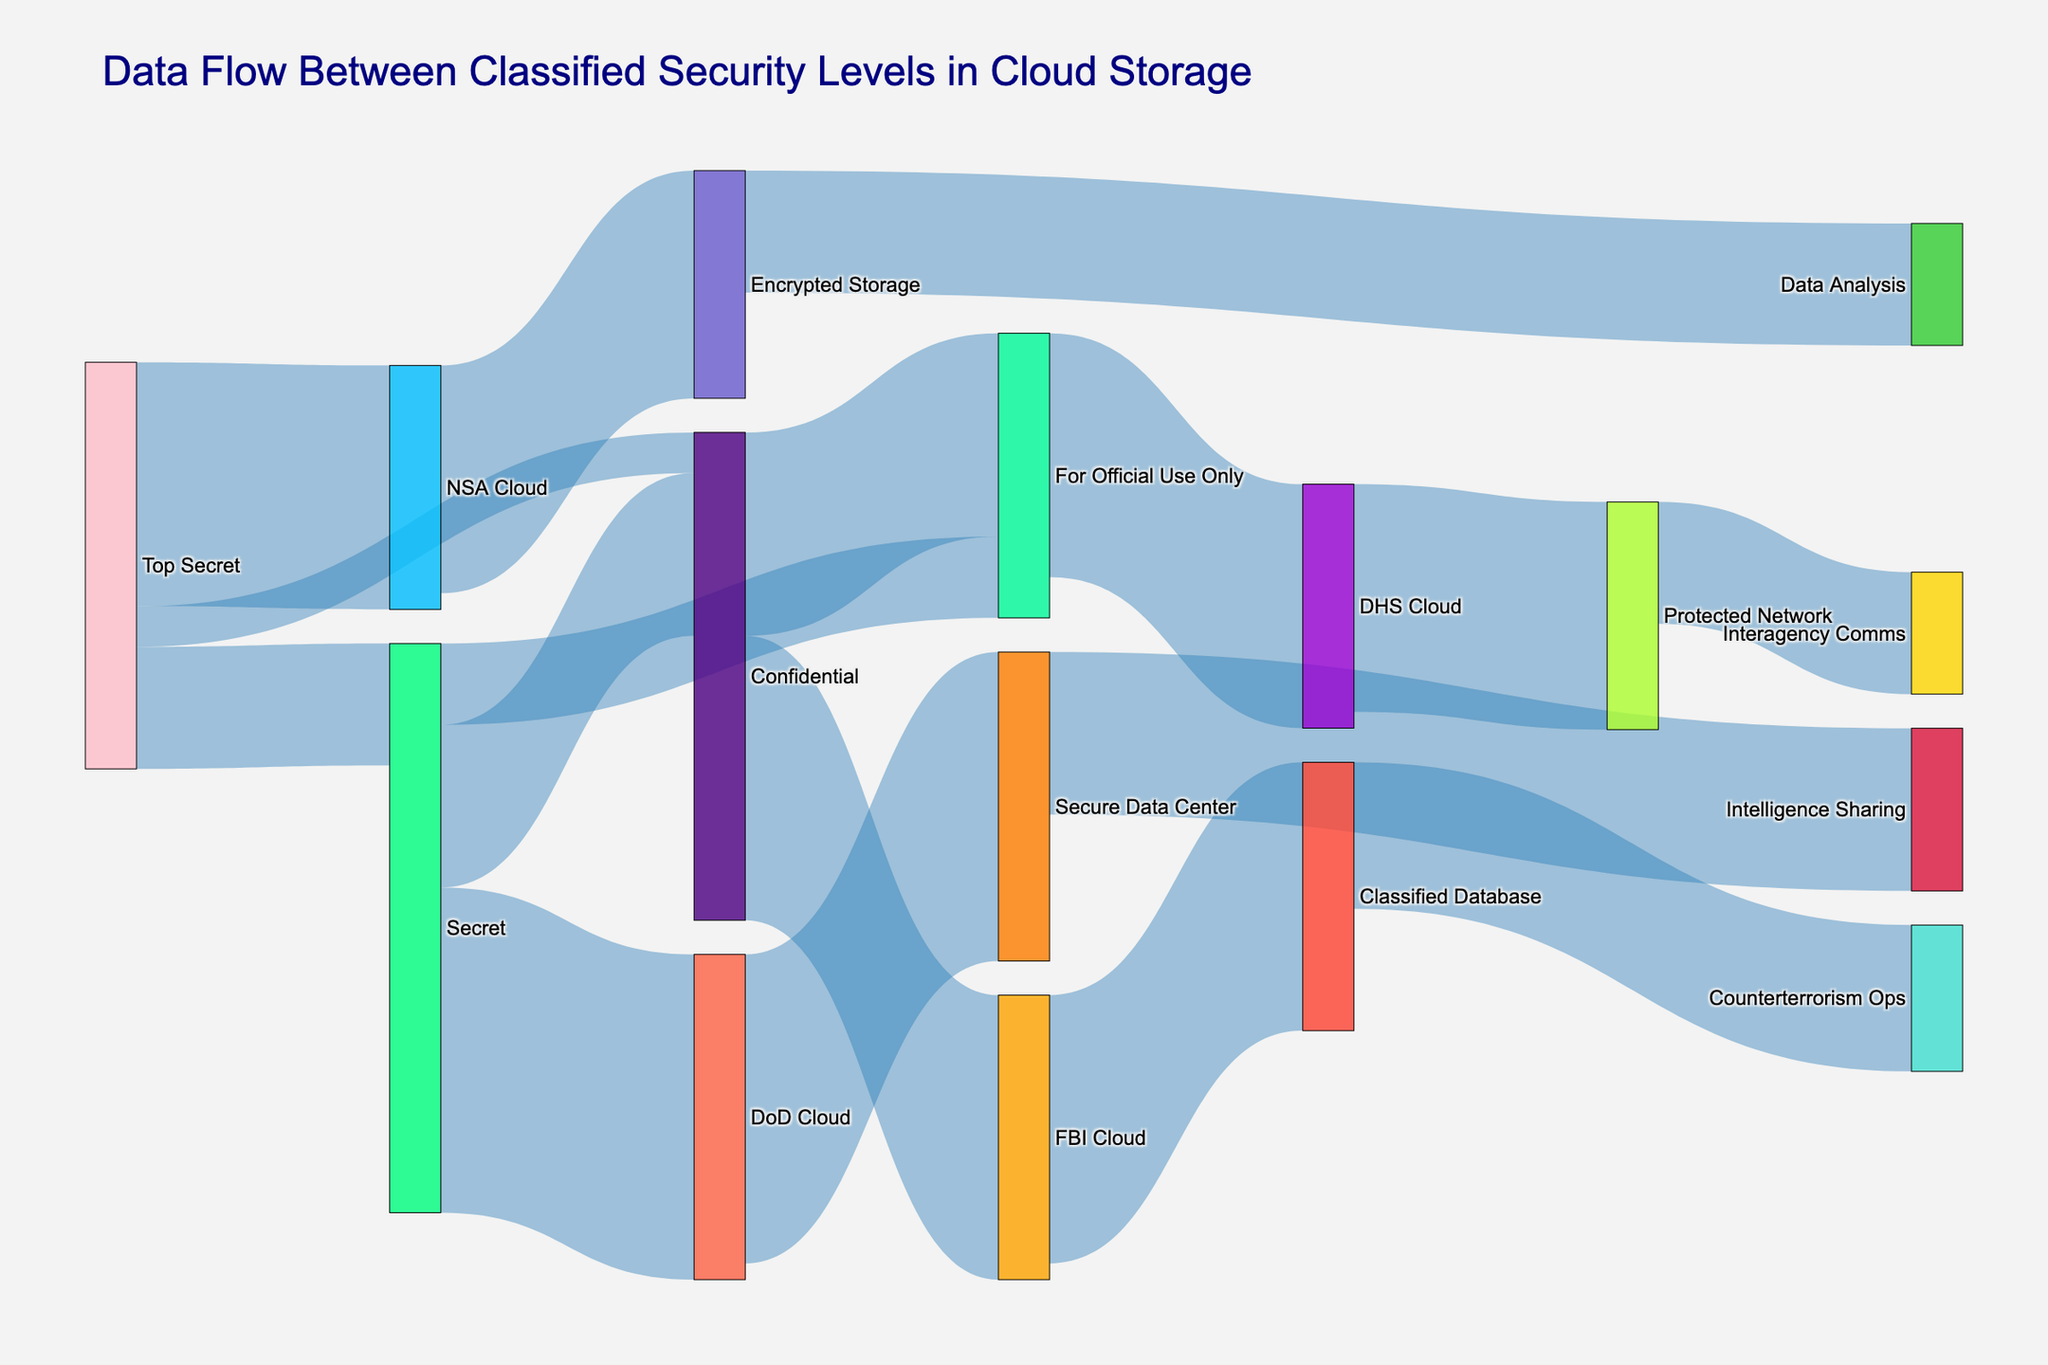What's the total data flow from "Top Secret" to other levels? We need to sum the data values flowing from "Top Secret" to other points: Top Secret -> Secret (150), Top Secret -> Confidential (50), and Top Secret -> NSA Cloud (300). 150 + 50 + 300 = 500.
Answer: 500 Which target receives the most data from "Secret"? Find the values for data flow from "Secret" to each target: Secret -> Confidential (200), Secret -> For Official Use Only (100), and Secret -> DoD Cloud (400). The highest value is 400, which goes to DoD Cloud.
Answer: DoD Cloud What's the difference in data flow between "Confidential" to "For Official Use Only" and "FBI Cloud"? From the figure, we see Confidential -> For Official Use Only is 250 and Confidential -> FBI Cloud is 350. The difference is 350 - 250 = 100.
Answer: 100 What's the smallest data flow value depicted? Identify the smallest values: 50 (Top Secret -> Confidential), 100 (Secret -> For Official Use Only). The smallest is 50.
Answer: 50 How many distinct security levels and cloud storage systems are represented? Count the unique nodes: Top Secret, Secret, Confidential, For Official Use Only (4 security levels), NSA Cloud, DoD Cloud, FBI Cloud, DHS Cloud (4 cloud systems). There are 8 distinct entities.
Answer: 8 From which security level does data flow directly to "Intelligence Sharing"? Look at the figure for direct links to Intelligence Sharing: Secure Data Center -> Intelligence Sharing (200). The Secure Data Center is sourced from DoD Cloud, which gets data from Secret.
Answer: Secret Which entity processes data for "Counterterrorism Ops"? Counterterrorism Ops directly receives data from the Classified Database, which gets its data from FBI Cloud.
Answer: FBI Cloud Is there more data flowing to "Protected Network" from "For Official Use Only" or to "Interagency Comms" from "Protected Network"? Compare the two values: For Official Use Only -> Protected Network (280) and Protected Network -> Interagency Comms (150). The higher value is 280.
Answer: For Official Use Only to Protected Network What's the total data flow from all clouds combined to their respective targets? Sum the data values for data flow from each cloud system: NSA Cloud -> Encrypted Storage (280), DoD Cloud -> Secure Data Center (380), FBI Cloud -> Classified Database (330), DHS Cloud -> Protected Network (280). The total is 280 + 380 + 330 + 280 = 1270.
Answer: 1270 